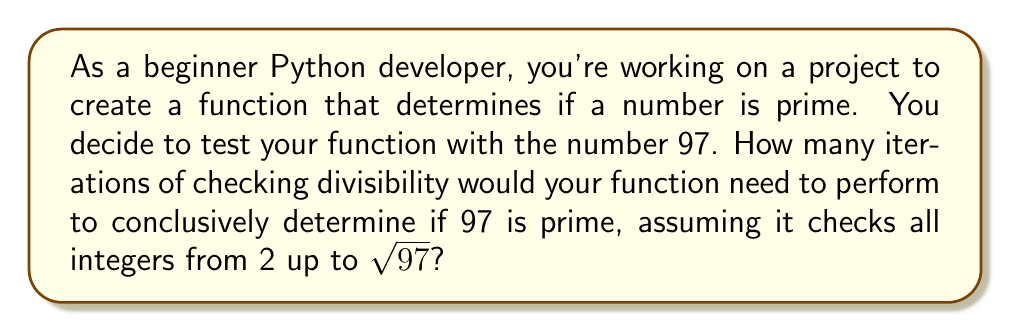What is the answer to this math problem? Let's approach this step-by-step:

1) To determine if a number $n$ is prime, we only need to check divisibility up to $\sqrt{n}$. This is because if $n$ is divisible by a number greater than its square root, the other factor would be less than $\sqrt{n}$, which we would have already checked.

2) For 97, we need to calculate $\sqrt{97}$:
   $\sqrt{97} \approx 9.8489$

3) Since we're only checking integers, we round down to 9.

4) Now, we need to count the integers from 2 to 9 inclusive:
   2, 3, 4, 5, 6, 7, 8, 9

5) Counting these numbers, we get 8 integers.

6) Therefore, a function would need to perform 8 divisibility checks to determine if 97 is prime.

Note: In an actual Python implementation, you might optimize this further by only checking odd numbers after 2, but the question asks for all integers up to $\sqrt{97}$.
Answer: 8 